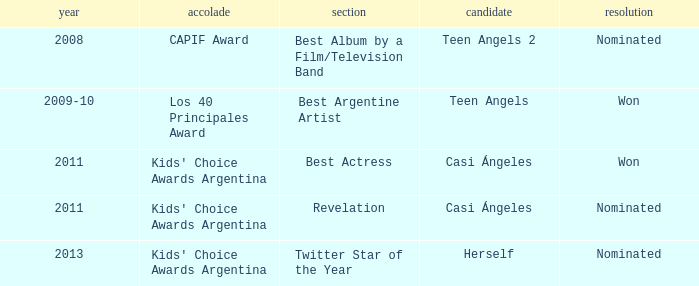Name the performance nominated for a Capif Award. Teen Angels 2. 